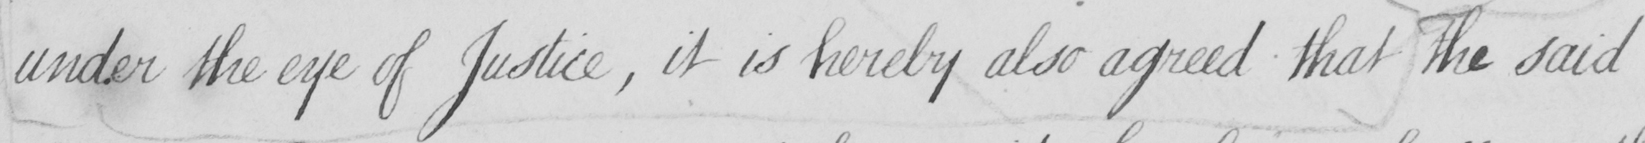What text is written in this handwritten line? under the eye of Justice , it is hereby also agreed that the said 